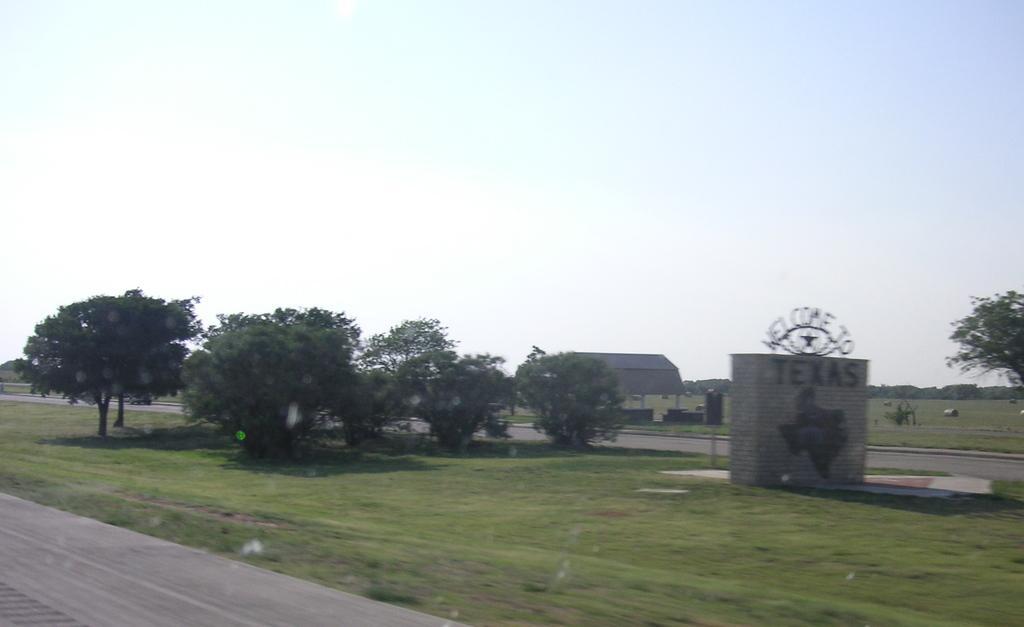Please provide a concise description of this image. In the picture I can see trees, the grass, a building and some other objects on the ground. In the background I can see the sky. 